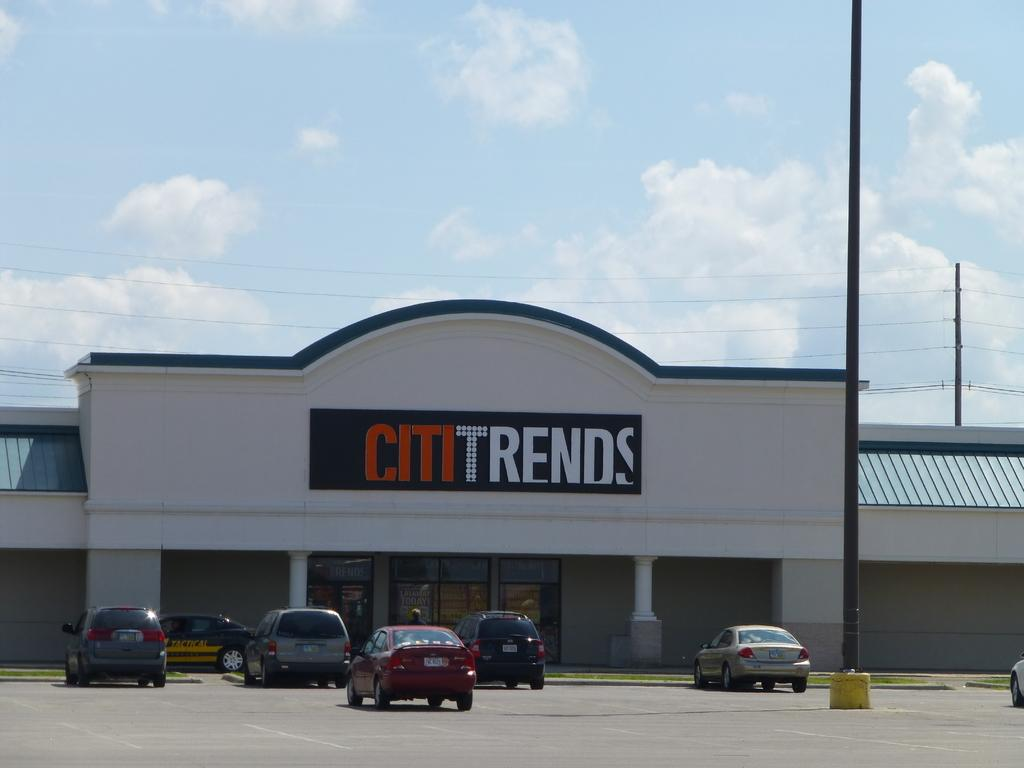What can be seen on the road in the image? There are vehicles on the road in the image. What object is present in the image that is not a vehicle or a house? There is a pole in the image. What type of structure is visible with some text on it? There is a house with some text in the image. What is visible at the top of the image? The sky is visible at the top of the image. What can be observed in the sky? Clouds are present in the sky. What type of brass instrument is being played by the minister in the image? There is no brass instrument or minister present in the image. What type of road is visible in the image? The image only shows vehicles on a road, but it does not provide information about the type of road. 